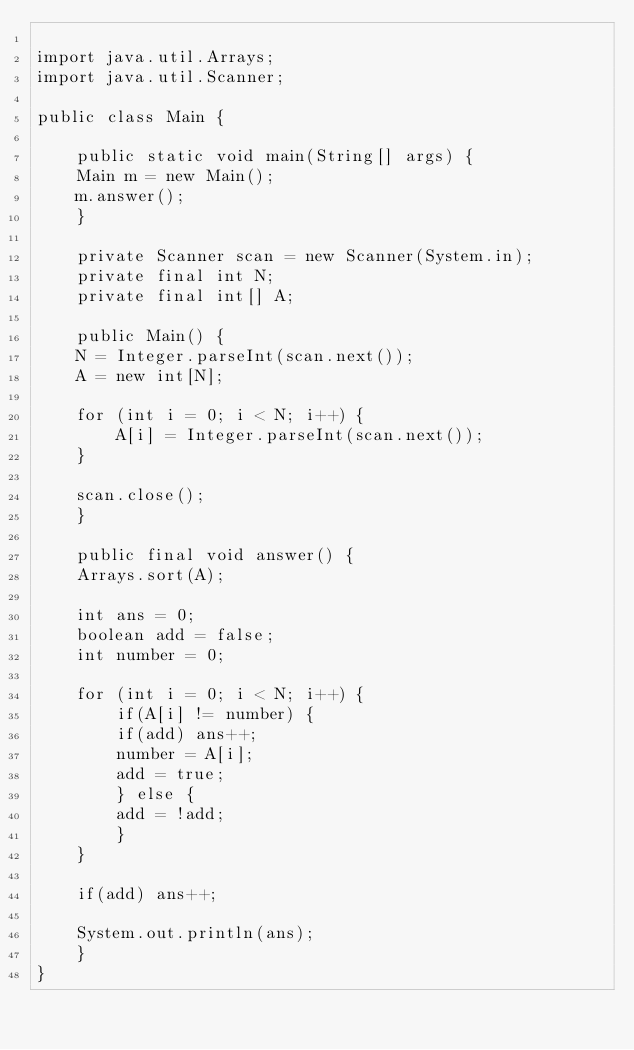Convert code to text. <code><loc_0><loc_0><loc_500><loc_500><_Java_>
import java.util.Arrays;
import java.util.Scanner;

public class Main {

    public static void main(String[] args) {
	Main m = new Main();
	m.answer();
    }

    private Scanner scan = new Scanner(System.in);
    private final int N;
    private final int[] A;

    public Main() {
	N = Integer.parseInt(scan.next());
	A = new int[N];

	for (int i = 0; i < N; i++) {
	    A[i] = Integer.parseInt(scan.next());
	}

	scan.close();
    }

    public final void answer() {
	Arrays.sort(A);

	int ans = 0;
	boolean add = false;
	int number = 0;

	for (int i = 0; i < N; i++) {
	    if(A[i] != number) {
		if(add) ans++;
		number = A[i];
		add = true;
	    } else {
		add = !add;
	    }
	}

	if(add) ans++;

	System.out.println(ans);
    }
}
</code> 